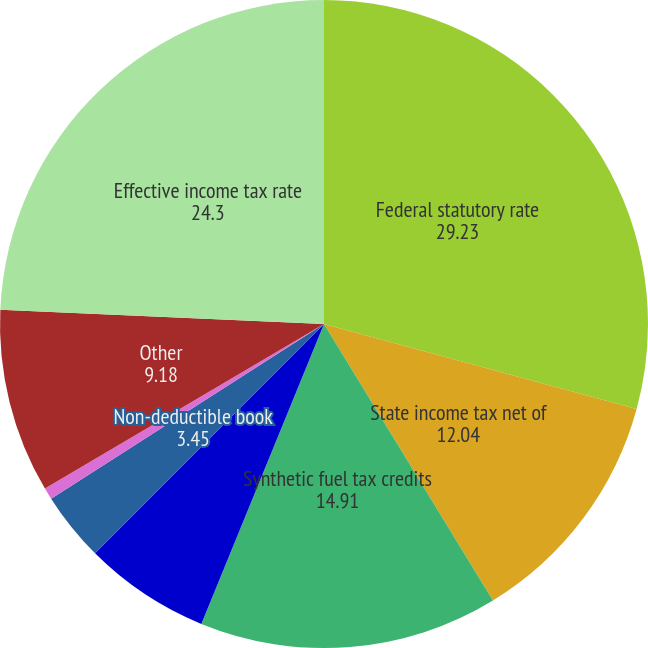Convert chart. <chart><loc_0><loc_0><loc_500><loc_500><pie_chart><fcel>Federal statutory rate<fcel>State income tax net of<fcel>Synthetic fuel tax credits<fcel>Employee stock plans dividend<fcel>Non-deductible book<fcel>Difference in prior years'<fcel>Other<fcel>Effective income tax rate<nl><fcel>29.23%<fcel>12.04%<fcel>14.91%<fcel>6.31%<fcel>3.45%<fcel>0.58%<fcel>9.18%<fcel>24.3%<nl></chart> 